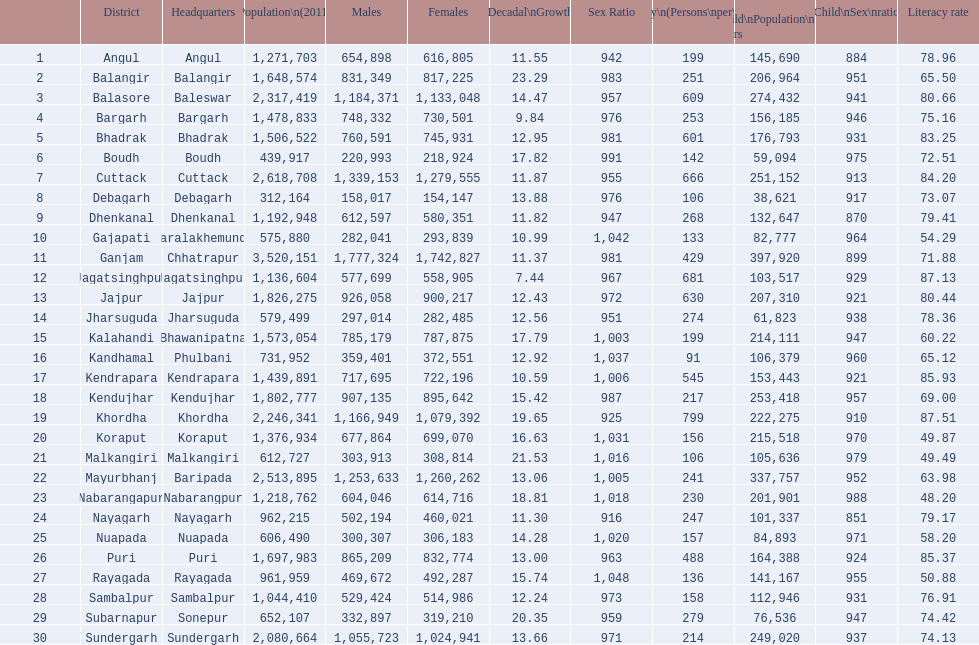In which district was the population growth the lowest between 2001 and 2011? Jagatsinghpur. 